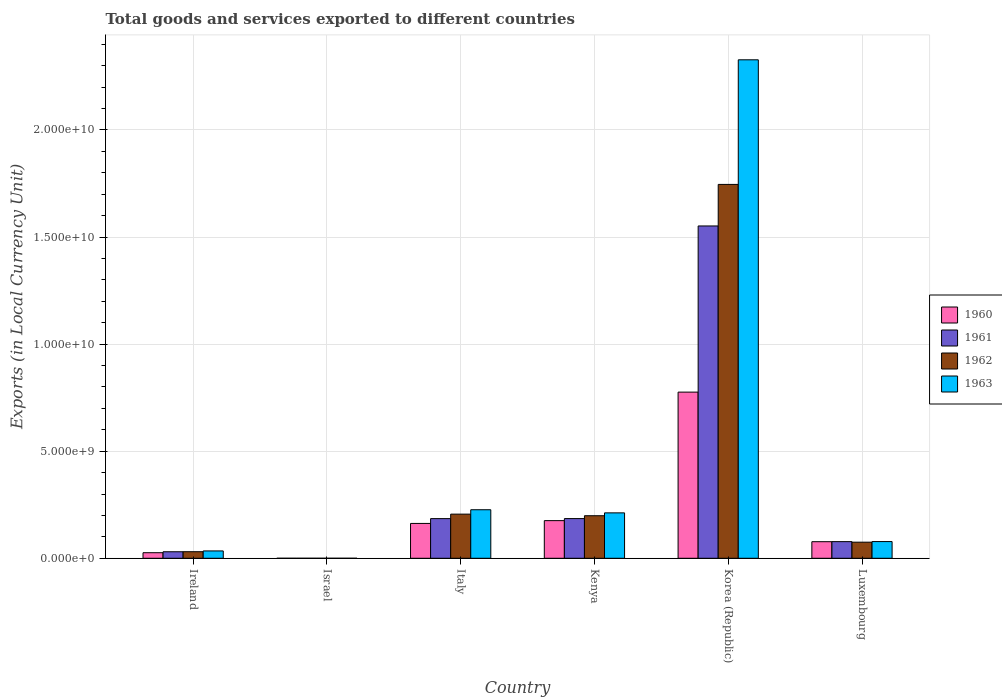How many different coloured bars are there?
Provide a short and direct response. 4. How many groups of bars are there?
Make the answer very short. 6. Are the number of bars on each tick of the X-axis equal?
Your answer should be very brief. Yes. How many bars are there on the 5th tick from the left?
Provide a short and direct response. 4. What is the label of the 4th group of bars from the left?
Offer a very short reply. Kenya. What is the Amount of goods and services exports in 1960 in Korea (Republic)?
Offer a terse response. 7.76e+09. Across all countries, what is the maximum Amount of goods and services exports in 1962?
Your answer should be very brief. 1.75e+1. Across all countries, what is the minimum Amount of goods and services exports in 1961?
Give a very brief answer. 7.24e+04. In which country was the Amount of goods and services exports in 1960 maximum?
Offer a terse response. Korea (Republic). What is the total Amount of goods and services exports in 1961 in the graph?
Ensure brevity in your answer.  2.03e+1. What is the difference between the Amount of goods and services exports in 1962 in Korea (Republic) and that in Luxembourg?
Provide a short and direct response. 1.67e+1. What is the difference between the Amount of goods and services exports in 1963 in Kenya and the Amount of goods and services exports in 1962 in Luxembourg?
Your answer should be compact. 1.37e+09. What is the average Amount of goods and services exports in 1963 per country?
Your response must be concise. 4.80e+09. What is the difference between the Amount of goods and services exports of/in 1961 and Amount of goods and services exports of/in 1962 in Korea (Republic)?
Offer a terse response. -1.94e+09. In how many countries, is the Amount of goods and services exports in 1963 greater than 6000000000 LCU?
Keep it short and to the point. 1. What is the ratio of the Amount of goods and services exports in 1961 in Italy to that in Kenya?
Keep it short and to the point. 1. Is the difference between the Amount of goods and services exports in 1961 in Italy and Kenya greater than the difference between the Amount of goods and services exports in 1962 in Italy and Kenya?
Give a very brief answer. No. What is the difference between the highest and the second highest Amount of goods and services exports in 1962?
Your answer should be compact. 1.55e+1. What is the difference between the highest and the lowest Amount of goods and services exports in 1960?
Keep it short and to the point. 7.76e+09. Is the sum of the Amount of goods and services exports in 1960 in Italy and Luxembourg greater than the maximum Amount of goods and services exports in 1962 across all countries?
Make the answer very short. No. What does the 1st bar from the right in Israel represents?
Ensure brevity in your answer.  1963. How many countries are there in the graph?
Your response must be concise. 6. Does the graph contain any zero values?
Offer a very short reply. No. How are the legend labels stacked?
Offer a terse response. Vertical. What is the title of the graph?
Ensure brevity in your answer.  Total goods and services exported to different countries. Does "1985" appear as one of the legend labels in the graph?
Your response must be concise. No. What is the label or title of the X-axis?
Give a very brief answer. Country. What is the label or title of the Y-axis?
Offer a terse response. Exports (in Local Currency Unit). What is the Exports (in Local Currency Unit) in 1960 in Ireland?
Keep it short and to the point. 2.60e+08. What is the Exports (in Local Currency Unit) in 1961 in Ireland?
Provide a short and direct response. 3.04e+08. What is the Exports (in Local Currency Unit) in 1962 in Ireland?
Give a very brief answer. 3.07e+08. What is the Exports (in Local Currency Unit) in 1963 in Ireland?
Offer a very short reply. 3.43e+08. What is the Exports (in Local Currency Unit) of 1960 in Israel?
Your answer should be compact. 6.19e+04. What is the Exports (in Local Currency Unit) of 1961 in Israel?
Your answer should be very brief. 7.24e+04. What is the Exports (in Local Currency Unit) in 1962 in Israel?
Your answer should be very brief. 1.34e+05. What is the Exports (in Local Currency Unit) of 1963 in Israel?
Offer a terse response. 1.67e+05. What is the Exports (in Local Currency Unit) of 1960 in Italy?
Your answer should be compact. 1.63e+09. What is the Exports (in Local Currency Unit) in 1961 in Italy?
Provide a succinct answer. 1.85e+09. What is the Exports (in Local Currency Unit) of 1962 in Italy?
Offer a very short reply. 2.06e+09. What is the Exports (in Local Currency Unit) of 1963 in Italy?
Provide a short and direct response. 2.27e+09. What is the Exports (in Local Currency Unit) in 1960 in Kenya?
Your answer should be compact. 1.76e+09. What is the Exports (in Local Currency Unit) in 1961 in Kenya?
Your answer should be compact. 1.85e+09. What is the Exports (in Local Currency Unit) in 1962 in Kenya?
Give a very brief answer. 1.99e+09. What is the Exports (in Local Currency Unit) in 1963 in Kenya?
Your answer should be compact. 2.12e+09. What is the Exports (in Local Currency Unit) in 1960 in Korea (Republic)?
Keep it short and to the point. 7.76e+09. What is the Exports (in Local Currency Unit) of 1961 in Korea (Republic)?
Provide a short and direct response. 1.55e+1. What is the Exports (in Local Currency Unit) of 1962 in Korea (Republic)?
Provide a short and direct response. 1.75e+1. What is the Exports (in Local Currency Unit) of 1963 in Korea (Republic)?
Ensure brevity in your answer.  2.33e+1. What is the Exports (in Local Currency Unit) in 1960 in Luxembourg?
Your answer should be very brief. 7.74e+08. What is the Exports (in Local Currency Unit) in 1961 in Luxembourg?
Ensure brevity in your answer.  7.77e+08. What is the Exports (in Local Currency Unit) in 1962 in Luxembourg?
Ensure brevity in your answer.  7.52e+08. What is the Exports (in Local Currency Unit) in 1963 in Luxembourg?
Provide a short and direct response. 7.80e+08. Across all countries, what is the maximum Exports (in Local Currency Unit) of 1960?
Keep it short and to the point. 7.76e+09. Across all countries, what is the maximum Exports (in Local Currency Unit) of 1961?
Provide a short and direct response. 1.55e+1. Across all countries, what is the maximum Exports (in Local Currency Unit) of 1962?
Make the answer very short. 1.75e+1. Across all countries, what is the maximum Exports (in Local Currency Unit) in 1963?
Provide a short and direct response. 2.33e+1. Across all countries, what is the minimum Exports (in Local Currency Unit) of 1960?
Give a very brief answer. 6.19e+04. Across all countries, what is the minimum Exports (in Local Currency Unit) of 1961?
Provide a short and direct response. 7.24e+04. Across all countries, what is the minimum Exports (in Local Currency Unit) of 1962?
Your answer should be very brief. 1.34e+05. Across all countries, what is the minimum Exports (in Local Currency Unit) of 1963?
Your response must be concise. 1.67e+05. What is the total Exports (in Local Currency Unit) of 1960 in the graph?
Your answer should be compact. 1.22e+1. What is the total Exports (in Local Currency Unit) of 1961 in the graph?
Make the answer very short. 2.03e+1. What is the total Exports (in Local Currency Unit) of 1962 in the graph?
Provide a succinct answer. 2.26e+1. What is the total Exports (in Local Currency Unit) in 1963 in the graph?
Keep it short and to the point. 2.88e+1. What is the difference between the Exports (in Local Currency Unit) of 1960 in Ireland and that in Israel?
Your answer should be very brief. 2.60e+08. What is the difference between the Exports (in Local Currency Unit) in 1961 in Ireland and that in Israel?
Your response must be concise. 3.04e+08. What is the difference between the Exports (in Local Currency Unit) of 1962 in Ireland and that in Israel?
Provide a succinct answer. 3.06e+08. What is the difference between the Exports (in Local Currency Unit) of 1963 in Ireland and that in Israel?
Your answer should be compact. 3.43e+08. What is the difference between the Exports (in Local Currency Unit) of 1960 in Ireland and that in Italy?
Offer a very short reply. -1.37e+09. What is the difference between the Exports (in Local Currency Unit) in 1961 in Ireland and that in Italy?
Make the answer very short. -1.55e+09. What is the difference between the Exports (in Local Currency Unit) in 1962 in Ireland and that in Italy?
Ensure brevity in your answer.  -1.75e+09. What is the difference between the Exports (in Local Currency Unit) of 1963 in Ireland and that in Italy?
Ensure brevity in your answer.  -1.92e+09. What is the difference between the Exports (in Local Currency Unit) of 1960 in Ireland and that in Kenya?
Your response must be concise. -1.50e+09. What is the difference between the Exports (in Local Currency Unit) in 1961 in Ireland and that in Kenya?
Your response must be concise. -1.55e+09. What is the difference between the Exports (in Local Currency Unit) of 1962 in Ireland and that in Kenya?
Provide a short and direct response. -1.68e+09. What is the difference between the Exports (in Local Currency Unit) of 1963 in Ireland and that in Kenya?
Offer a very short reply. -1.78e+09. What is the difference between the Exports (in Local Currency Unit) in 1960 in Ireland and that in Korea (Republic)?
Ensure brevity in your answer.  -7.50e+09. What is the difference between the Exports (in Local Currency Unit) of 1961 in Ireland and that in Korea (Republic)?
Your answer should be very brief. -1.52e+1. What is the difference between the Exports (in Local Currency Unit) of 1962 in Ireland and that in Korea (Republic)?
Keep it short and to the point. -1.72e+1. What is the difference between the Exports (in Local Currency Unit) of 1963 in Ireland and that in Korea (Republic)?
Give a very brief answer. -2.29e+1. What is the difference between the Exports (in Local Currency Unit) of 1960 in Ireland and that in Luxembourg?
Provide a succinct answer. -5.14e+08. What is the difference between the Exports (in Local Currency Unit) in 1961 in Ireland and that in Luxembourg?
Your response must be concise. -4.73e+08. What is the difference between the Exports (in Local Currency Unit) in 1962 in Ireland and that in Luxembourg?
Your response must be concise. -4.45e+08. What is the difference between the Exports (in Local Currency Unit) in 1963 in Ireland and that in Luxembourg?
Your answer should be compact. -4.37e+08. What is the difference between the Exports (in Local Currency Unit) in 1960 in Israel and that in Italy?
Keep it short and to the point. -1.63e+09. What is the difference between the Exports (in Local Currency Unit) in 1961 in Israel and that in Italy?
Give a very brief answer. -1.85e+09. What is the difference between the Exports (in Local Currency Unit) in 1962 in Israel and that in Italy?
Your answer should be very brief. -2.06e+09. What is the difference between the Exports (in Local Currency Unit) in 1963 in Israel and that in Italy?
Your answer should be very brief. -2.27e+09. What is the difference between the Exports (in Local Currency Unit) of 1960 in Israel and that in Kenya?
Give a very brief answer. -1.76e+09. What is the difference between the Exports (in Local Currency Unit) of 1961 in Israel and that in Kenya?
Your answer should be compact. -1.85e+09. What is the difference between the Exports (in Local Currency Unit) of 1962 in Israel and that in Kenya?
Offer a very short reply. -1.99e+09. What is the difference between the Exports (in Local Currency Unit) of 1963 in Israel and that in Kenya?
Your answer should be very brief. -2.12e+09. What is the difference between the Exports (in Local Currency Unit) in 1960 in Israel and that in Korea (Republic)?
Provide a short and direct response. -7.76e+09. What is the difference between the Exports (in Local Currency Unit) in 1961 in Israel and that in Korea (Republic)?
Provide a succinct answer. -1.55e+1. What is the difference between the Exports (in Local Currency Unit) of 1962 in Israel and that in Korea (Republic)?
Provide a short and direct response. -1.75e+1. What is the difference between the Exports (in Local Currency Unit) of 1963 in Israel and that in Korea (Republic)?
Provide a short and direct response. -2.33e+1. What is the difference between the Exports (in Local Currency Unit) of 1960 in Israel and that in Luxembourg?
Make the answer very short. -7.74e+08. What is the difference between the Exports (in Local Currency Unit) in 1961 in Israel and that in Luxembourg?
Keep it short and to the point. -7.77e+08. What is the difference between the Exports (in Local Currency Unit) in 1962 in Israel and that in Luxembourg?
Offer a terse response. -7.52e+08. What is the difference between the Exports (in Local Currency Unit) in 1963 in Israel and that in Luxembourg?
Make the answer very short. -7.79e+08. What is the difference between the Exports (in Local Currency Unit) in 1960 in Italy and that in Kenya?
Give a very brief answer. -1.31e+08. What is the difference between the Exports (in Local Currency Unit) in 1961 in Italy and that in Kenya?
Ensure brevity in your answer.  -1.45e+06. What is the difference between the Exports (in Local Currency Unit) of 1962 in Italy and that in Kenya?
Keep it short and to the point. 7.40e+07. What is the difference between the Exports (in Local Currency Unit) in 1963 in Italy and that in Kenya?
Your response must be concise. 1.46e+08. What is the difference between the Exports (in Local Currency Unit) in 1960 in Italy and that in Korea (Republic)?
Give a very brief answer. -6.13e+09. What is the difference between the Exports (in Local Currency Unit) of 1961 in Italy and that in Korea (Republic)?
Your response must be concise. -1.37e+1. What is the difference between the Exports (in Local Currency Unit) of 1962 in Italy and that in Korea (Republic)?
Keep it short and to the point. -1.54e+1. What is the difference between the Exports (in Local Currency Unit) in 1963 in Italy and that in Korea (Republic)?
Keep it short and to the point. -2.10e+1. What is the difference between the Exports (in Local Currency Unit) in 1960 in Italy and that in Luxembourg?
Offer a very short reply. 8.53e+08. What is the difference between the Exports (in Local Currency Unit) of 1961 in Italy and that in Luxembourg?
Provide a succinct answer. 1.07e+09. What is the difference between the Exports (in Local Currency Unit) of 1962 in Italy and that in Luxembourg?
Provide a short and direct response. 1.31e+09. What is the difference between the Exports (in Local Currency Unit) of 1963 in Italy and that in Luxembourg?
Keep it short and to the point. 1.49e+09. What is the difference between the Exports (in Local Currency Unit) in 1960 in Kenya and that in Korea (Republic)?
Provide a short and direct response. -6.00e+09. What is the difference between the Exports (in Local Currency Unit) of 1961 in Kenya and that in Korea (Republic)?
Your answer should be compact. -1.37e+1. What is the difference between the Exports (in Local Currency Unit) of 1962 in Kenya and that in Korea (Republic)?
Ensure brevity in your answer.  -1.55e+1. What is the difference between the Exports (in Local Currency Unit) of 1963 in Kenya and that in Korea (Republic)?
Provide a short and direct response. -2.12e+1. What is the difference between the Exports (in Local Currency Unit) of 1960 in Kenya and that in Luxembourg?
Make the answer very short. 9.84e+08. What is the difference between the Exports (in Local Currency Unit) in 1961 in Kenya and that in Luxembourg?
Your answer should be compact. 1.08e+09. What is the difference between the Exports (in Local Currency Unit) in 1962 in Kenya and that in Luxembourg?
Your response must be concise. 1.23e+09. What is the difference between the Exports (in Local Currency Unit) of 1963 in Kenya and that in Luxembourg?
Provide a succinct answer. 1.34e+09. What is the difference between the Exports (in Local Currency Unit) in 1960 in Korea (Republic) and that in Luxembourg?
Your answer should be very brief. 6.98e+09. What is the difference between the Exports (in Local Currency Unit) of 1961 in Korea (Republic) and that in Luxembourg?
Your response must be concise. 1.47e+1. What is the difference between the Exports (in Local Currency Unit) of 1962 in Korea (Republic) and that in Luxembourg?
Make the answer very short. 1.67e+1. What is the difference between the Exports (in Local Currency Unit) of 1963 in Korea (Republic) and that in Luxembourg?
Your response must be concise. 2.25e+1. What is the difference between the Exports (in Local Currency Unit) of 1960 in Ireland and the Exports (in Local Currency Unit) of 1961 in Israel?
Offer a terse response. 2.60e+08. What is the difference between the Exports (in Local Currency Unit) in 1960 in Ireland and the Exports (in Local Currency Unit) in 1962 in Israel?
Provide a short and direct response. 2.60e+08. What is the difference between the Exports (in Local Currency Unit) in 1960 in Ireland and the Exports (in Local Currency Unit) in 1963 in Israel?
Provide a short and direct response. 2.60e+08. What is the difference between the Exports (in Local Currency Unit) in 1961 in Ireland and the Exports (in Local Currency Unit) in 1962 in Israel?
Give a very brief answer. 3.04e+08. What is the difference between the Exports (in Local Currency Unit) of 1961 in Ireland and the Exports (in Local Currency Unit) of 1963 in Israel?
Your answer should be very brief. 3.04e+08. What is the difference between the Exports (in Local Currency Unit) of 1962 in Ireland and the Exports (in Local Currency Unit) of 1963 in Israel?
Provide a succinct answer. 3.06e+08. What is the difference between the Exports (in Local Currency Unit) in 1960 in Ireland and the Exports (in Local Currency Unit) in 1961 in Italy?
Your answer should be very brief. -1.59e+09. What is the difference between the Exports (in Local Currency Unit) in 1960 in Ireland and the Exports (in Local Currency Unit) in 1962 in Italy?
Provide a succinct answer. -1.80e+09. What is the difference between the Exports (in Local Currency Unit) in 1960 in Ireland and the Exports (in Local Currency Unit) in 1963 in Italy?
Keep it short and to the point. -2.01e+09. What is the difference between the Exports (in Local Currency Unit) in 1961 in Ireland and the Exports (in Local Currency Unit) in 1962 in Italy?
Provide a succinct answer. -1.76e+09. What is the difference between the Exports (in Local Currency Unit) of 1961 in Ireland and the Exports (in Local Currency Unit) of 1963 in Italy?
Offer a terse response. -1.96e+09. What is the difference between the Exports (in Local Currency Unit) of 1962 in Ireland and the Exports (in Local Currency Unit) of 1963 in Italy?
Give a very brief answer. -1.96e+09. What is the difference between the Exports (in Local Currency Unit) of 1960 in Ireland and the Exports (in Local Currency Unit) of 1961 in Kenya?
Offer a very short reply. -1.59e+09. What is the difference between the Exports (in Local Currency Unit) of 1960 in Ireland and the Exports (in Local Currency Unit) of 1962 in Kenya?
Your response must be concise. -1.73e+09. What is the difference between the Exports (in Local Currency Unit) in 1960 in Ireland and the Exports (in Local Currency Unit) in 1963 in Kenya?
Your answer should be very brief. -1.86e+09. What is the difference between the Exports (in Local Currency Unit) of 1961 in Ireland and the Exports (in Local Currency Unit) of 1962 in Kenya?
Keep it short and to the point. -1.68e+09. What is the difference between the Exports (in Local Currency Unit) in 1961 in Ireland and the Exports (in Local Currency Unit) in 1963 in Kenya?
Your answer should be very brief. -1.82e+09. What is the difference between the Exports (in Local Currency Unit) of 1962 in Ireland and the Exports (in Local Currency Unit) of 1963 in Kenya?
Give a very brief answer. -1.81e+09. What is the difference between the Exports (in Local Currency Unit) of 1960 in Ireland and the Exports (in Local Currency Unit) of 1961 in Korea (Republic)?
Give a very brief answer. -1.53e+1. What is the difference between the Exports (in Local Currency Unit) of 1960 in Ireland and the Exports (in Local Currency Unit) of 1962 in Korea (Republic)?
Your response must be concise. -1.72e+1. What is the difference between the Exports (in Local Currency Unit) in 1960 in Ireland and the Exports (in Local Currency Unit) in 1963 in Korea (Republic)?
Your response must be concise. -2.30e+1. What is the difference between the Exports (in Local Currency Unit) in 1961 in Ireland and the Exports (in Local Currency Unit) in 1962 in Korea (Republic)?
Your response must be concise. -1.72e+1. What is the difference between the Exports (in Local Currency Unit) in 1961 in Ireland and the Exports (in Local Currency Unit) in 1963 in Korea (Republic)?
Provide a short and direct response. -2.30e+1. What is the difference between the Exports (in Local Currency Unit) of 1962 in Ireland and the Exports (in Local Currency Unit) of 1963 in Korea (Republic)?
Ensure brevity in your answer.  -2.30e+1. What is the difference between the Exports (in Local Currency Unit) of 1960 in Ireland and the Exports (in Local Currency Unit) of 1961 in Luxembourg?
Offer a terse response. -5.17e+08. What is the difference between the Exports (in Local Currency Unit) in 1960 in Ireland and the Exports (in Local Currency Unit) in 1962 in Luxembourg?
Offer a terse response. -4.92e+08. What is the difference between the Exports (in Local Currency Unit) of 1960 in Ireland and the Exports (in Local Currency Unit) of 1963 in Luxembourg?
Offer a terse response. -5.20e+08. What is the difference between the Exports (in Local Currency Unit) in 1961 in Ireland and the Exports (in Local Currency Unit) in 1962 in Luxembourg?
Make the answer very short. -4.48e+08. What is the difference between the Exports (in Local Currency Unit) of 1961 in Ireland and the Exports (in Local Currency Unit) of 1963 in Luxembourg?
Offer a terse response. -4.76e+08. What is the difference between the Exports (in Local Currency Unit) of 1962 in Ireland and the Exports (in Local Currency Unit) of 1963 in Luxembourg?
Ensure brevity in your answer.  -4.73e+08. What is the difference between the Exports (in Local Currency Unit) of 1960 in Israel and the Exports (in Local Currency Unit) of 1961 in Italy?
Offer a terse response. -1.85e+09. What is the difference between the Exports (in Local Currency Unit) in 1960 in Israel and the Exports (in Local Currency Unit) in 1962 in Italy?
Keep it short and to the point. -2.06e+09. What is the difference between the Exports (in Local Currency Unit) of 1960 in Israel and the Exports (in Local Currency Unit) of 1963 in Italy?
Offer a terse response. -2.27e+09. What is the difference between the Exports (in Local Currency Unit) in 1961 in Israel and the Exports (in Local Currency Unit) in 1962 in Italy?
Make the answer very short. -2.06e+09. What is the difference between the Exports (in Local Currency Unit) of 1961 in Israel and the Exports (in Local Currency Unit) of 1963 in Italy?
Your answer should be compact. -2.27e+09. What is the difference between the Exports (in Local Currency Unit) in 1962 in Israel and the Exports (in Local Currency Unit) in 1963 in Italy?
Your response must be concise. -2.27e+09. What is the difference between the Exports (in Local Currency Unit) of 1960 in Israel and the Exports (in Local Currency Unit) of 1961 in Kenya?
Give a very brief answer. -1.85e+09. What is the difference between the Exports (in Local Currency Unit) in 1960 in Israel and the Exports (in Local Currency Unit) in 1962 in Kenya?
Your response must be concise. -1.99e+09. What is the difference between the Exports (in Local Currency Unit) of 1960 in Israel and the Exports (in Local Currency Unit) of 1963 in Kenya?
Your answer should be very brief. -2.12e+09. What is the difference between the Exports (in Local Currency Unit) of 1961 in Israel and the Exports (in Local Currency Unit) of 1962 in Kenya?
Provide a succinct answer. -1.99e+09. What is the difference between the Exports (in Local Currency Unit) in 1961 in Israel and the Exports (in Local Currency Unit) in 1963 in Kenya?
Offer a terse response. -2.12e+09. What is the difference between the Exports (in Local Currency Unit) in 1962 in Israel and the Exports (in Local Currency Unit) in 1963 in Kenya?
Keep it short and to the point. -2.12e+09. What is the difference between the Exports (in Local Currency Unit) of 1960 in Israel and the Exports (in Local Currency Unit) of 1961 in Korea (Republic)?
Give a very brief answer. -1.55e+1. What is the difference between the Exports (in Local Currency Unit) of 1960 in Israel and the Exports (in Local Currency Unit) of 1962 in Korea (Republic)?
Your answer should be compact. -1.75e+1. What is the difference between the Exports (in Local Currency Unit) in 1960 in Israel and the Exports (in Local Currency Unit) in 1963 in Korea (Republic)?
Provide a succinct answer. -2.33e+1. What is the difference between the Exports (in Local Currency Unit) in 1961 in Israel and the Exports (in Local Currency Unit) in 1962 in Korea (Republic)?
Keep it short and to the point. -1.75e+1. What is the difference between the Exports (in Local Currency Unit) of 1961 in Israel and the Exports (in Local Currency Unit) of 1963 in Korea (Republic)?
Offer a terse response. -2.33e+1. What is the difference between the Exports (in Local Currency Unit) in 1962 in Israel and the Exports (in Local Currency Unit) in 1963 in Korea (Republic)?
Keep it short and to the point. -2.33e+1. What is the difference between the Exports (in Local Currency Unit) in 1960 in Israel and the Exports (in Local Currency Unit) in 1961 in Luxembourg?
Your response must be concise. -7.77e+08. What is the difference between the Exports (in Local Currency Unit) in 1960 in Israel and the Exports (in Local Currency Unit) in 1962 in Luxembourg?
Your answer should be compact. -7.52e+08. What is the difference between the Exports (in Local Currency Unit) of 1960 in Israel and the Exports (in Local Currency Unit) of 1963 in Luxembourg?
Ensure brevity in your answer.  -7.80e+08. What is the difference between the Exports (in Local Currency Unit) in 1961 in Israel and the Exports (in Local Currency Unit) in 1962 in Luxembourg?
Keep it short and to the point. -7.52e+08. What is the difference between the Exports (in Local Currency Unit) in 1961 in Israel and the Exports (in Local Currency Unit) in 1963 in Luxembourg?
Provide a short and direct response. -7.80e+08. What is the difference between the Exports (in Local Currency Unit) of 1962 in Israel and the Exports (in Local Currency Unit) of 1963 in Luxembourg?
Provide a short and direct response. -7.80e+08. What is the difference between the Exports (in Local Currency Unit) in 1960 in Italy and the Exports (in Local Currency Unit) in 1961 in Kenya?
Your answer should be compact. -2.27e+08. What is the difference between the Exports (in Local Currency Unit) in 1960 in Italy and the Exports (in Local Currency Unit) in 1962 in Kenya?
Your answer should be compact. -3.60e+08. What is the difference between the Exports (in Local Currency Unit) of 1960 in Italy and the Exports (in Local Currency Unit) of 1963 in Kenya?
Provide a short and direct response. -4.94e+08. What is the difference between the Exports (in Local Currency Unit) of 1961 in Italy and the Exports (in Local Currency Unit) of 1962 in Kenya?
Your answer should be compact. -1.35e+08. What is the difference between the Exports (in Local Currency Unit) of 1961 in Italy and the Exports (in Local Currency Unit) of 1963 in Kenya?
Offer a very short reply. -2.68e+08. What is the difference between the Exports (in Local Currency Unit) in 1962 in Italy and the Exports (in Local Currency Unit) in 1963 in Kenya?
Ensure brevity in your answer.  -5.95e+07. What is the difference between the Exports (in Local Currency Unit) of 1960 in Italy and the Exports (in Local Currency Unit) of 1961 in Korea (Republic)?
Make the answer very short. -1.39e+1. What is the difference between the Exports (in Local Currency Unit) of 1960 in Italy and the Exports (in Local Currency Unit) of 1962 in Korea (Republic)?
Provide a short and direct response. -1.58e+1. What is the difference between the Exports (in Local Currency Unit) in 1960 in Italy and the Exports (in Local Currency Unit) in 1963 in Korea (Republic)?
Your answer should be compact. -2.16e+1. What is the difference between the Exports (in Local Currency Unit) in 1961 in Italy and the Exports (in Local Currency Unit) in 1962 in Korea (Republic)?
Your answer should be very brief. -1.56e+1. What is the difference between the Exports (in Local Currency Unit) of 1961 in Italy and the Exports (in Local Currency Unit) of 1963 in Korea (Republic)?
Provide a succinct answer. -2.14e+1. What is the difference between the Exports (in Local Currency Unit) of 1962 in Italy and the Exports (in Local Currency Unit) of 1963 in Korea (Republic)?
Keep it short and to the point. -2.12e+1. What is the difference between the Exports (in Local Currency Unit) in 1960 in Italy and the Exports (in Local Currency Unit) in 1961 in Luxembourg?
Your answer should be very brief. 8.50e+08. What is the difference between the Exports (in Local Currency Unit) in 1960 in Italy and the Exports (in Local Currency Unit) in 1962 in Luxembourg?
Your response must be concise. 8.75e+08. What is the difference between the Exports (in Local Currency Unit) in 1960 in Italy and the Exports (in Local Currency Unit) in 1963 in Luxembourg?
Your answer should be very brief. 8.47e+08. What is the difference between the Exports (in Local Currency Unit) of 1961 in Italy and the Exports (in Local Currency Unit) of 1962 in Luxembourg?
Ensure brevity in your answer.  1.10e+09. What is the difference between the Exports (in Local Currency Unit) in 1961 in Italy and the Exports (in Local Currency Unit) in 1963 in Luxembourg?
Provide a short and direct response. 1.07e+09. What is the difference between the Exports (in Local Currency Unit) of 1962 in Italy and the Exports (in Local Currency Unit) of 1963 in Luxembourg?
Offer a terse response. 1.28e+09. What is the difference between the Exports (in Local Currency Unit) of 1960 in Kenya and the Exports (in Local Currency Unit) of 1961 in Korea (Republic)?
Your answer should be compact. -1.38e+1. What is the difference between the Exports (in Local Currency Unit) of 1960 in Kenya and the Exports (in Local Currency Unit) of 1962 in Korea (Republic)?
Keep it short and to the point. -1.57e+1. What is the difference between the Exports (in Local Currency Unit) of 1960 in Kenya and the Exports (in Local Currency Unit) of 1963 in Korea (Republic)?
Offer a terse response. -2.15e+1. What is the difference between the Exports (in Local Currency Unit) in 1961 in Kenya and the Exports (in Local Currency Unit) in 1962 in Korea (Republic)?
Provide a short and direct response. -1.56e+1. What is the difference between the Exports (in Local Currency Unit) in 1961 in Kenya and the Exports (in Local Currency Unit) in 1963 in Korea (Republic)?
Keep it short and to the point. -2.14e+1. What is the difference between the Exports (in Local Currency Unit) of 1962 in Kenya and the Exports (in Local Currency Unit) of 1963 in Korea (Republic)?
Offer a terse response. -2.13e+1. What is the difference between the Exports (in Local Currency Unit) of 1960 in Kenya and the Exports (in Local Currency Unit) of 1961 in Luxembourg?
Make the answer very short. 9.81e+08. What is the difference between the Exports (in Local Currency Unit) of 1960 in Kenya and the Exports (in Local Currency Unit) of 1962 in Luxembourg?
Give a very brief answer. 1.01e+09. What is the difference between the Exports (in Local Currency Unit) in 1960 in Kenya and the Exports (in Local Currency Unit) in 1963 in Luxembourg?
Your response must be concise. 9.78e+08. What is the difference between the Exports (in Local Currency Unit) of 1961 in Kenya and the Exports (in Local Currency Unit) of 1962 in Luxembourg?
Offer a terse response. 1.10e+09. What is the difference between the Exports (in Local Currency Unit) of 1961 in Kenya and the Exports (in Local Currency Unit) of 1963 in Luxembourg?
Give a very brief answer. 1.07e+09. What is the difference between the Exports (in Local Currency Unit) in 1962 in Kenya and the Exports (in Local Currency Unit) in 1963 in Luxembourg?
Provide a short and direct response. 1.21e+09. What is the difference between the Exports (in Local Currency Unit) of 1960 in Korea (Republic) and the Exports (in Local Currency Unit) of 1961 in Luxembourg?
Keep it short and to the point. 6.98e+09. What is the difference between the Exports (in Local Currency Unit) of 1960 in Korea (Republic) and the Exports (in Local Currency Unit) of 1962 in Luxembourg?
Offer a very short reply. 7.01e+09. What is the difference between the Exports (in Local Currency Unit) in 1960 in Korea (Republic) and the Exports (in Local Currency Unit) in 1963 in Luxembourg?
Your answer should be very brief. 6.98e+09. What is the difference between the Exports (in Local Currency Unit) in 1961 in Korea (Republic) and the Exports (in Local Currency Unit) in 1962 in Luxembourg?
Offer a very short reply. 1.48e+1. What is the difference between the Exports (in Local Currency Unit) of 1961 in Korea (Republic) and the Exports (in Local Currency Unit) of 1963 in Luxembourg?
Give a very brief answer. 1.47e+1. What is the difference between the Exports (in Local Currency Unit) of 1962 in Korea (Republic) and the Exports (in Local Currency Unit) of 1963 in Luxembourg?
Provide a succinct answer. 1.67e+1. What is the average Exports (in Local Currency Unit) in 1960 per country?
Your answer should be compact. 2.03e+09. What is the average Exports (in Local Currency Unit) in 1961 per country?
Give a very brief answer. 3.38e+09. What is the average Exports (in Local Currency Unit) in 1962 per country?
Your answer should be very brief. 3.76e+09. What is the average Exports (in Local Currency Unit) of 1963 per country?
Your answer should be very brief. 4.80e+09. What is the difference between the Exports (in Local Currency Unit) of 1960 and Exports (in Local Currency Unit) of 1961 in Ireland?
Offer a terse response. -4.43e+07. What is the difference between the Exports (in Local Currency Unit) of 1960 and Exports (in Local Currency Unit) of 1962 in Ireland?
Offer a very short reply. -4.69e+07. What is the difference between the Exports (in Local Currency Unit) in 1960 and Exports (in Local Currency Unit) in 1963 in Ireland?
Provide a short and direct response. -8.33e+07. What is the difference between the Exports (in Local Currency Unit) in 1961 and Exports (in Local Currency Unit) in 1962 in Ireland?
Offer a terse response. -2.58e+06. What is the difference between the Exports (in Local Currency Unit) of 1961 and Exports (in Local Currency Unit) of 1963 in Ireland?
Your answer should be compact. -3.90e+07. What is the difference between the Exports (in Local Currency Unit) of 1962 and Exports (in Local Currency Unit) of 1963 in Ireland?
Provide a short and direct response. -3.64e+07. What is the difference between the Exports (in Local Currency Unit) in 1960 and Exports (in Local Currency Unit) in 1961 in Israel?
Make the answer very short. -1.05e+04. What is the difference between the Exports (in Local Currency Unit) in 1960 and Exports (in Local Currency Unit) in 1962 in Israel?
Your answer should be very brief. -7.21e+04. What is the difference between the Exports (in Local Currency Unit) in 1960 and Exports (in Local Currency Unit) in 1963 in Israel?
Provide a succinct answer. -1.06e+05. What is the difference between the Exports (in Local Currency Unit) of 1961 and Exports (in Local Currency Unit) of 1962 in Israel?
Give a very brief answer. -6.16e+04. What is the difference between the Exports (in Local Currency Unit) of 1961 and Exports (in Local Currency Unit) of 1963 in Israel?
Your response must be concise. -9.50e+04. What is the difference between the Exports (in Local Currency Unit) of 1962 and Exports (in Local Currency Unit) of 1963 in Israel?
Your response must be concise. -3.34e+04. What is the difference between the Exports (in Local Currency Unit) in 1960 and Exports (in Local Currency Unit) in 1961 in Italy?
Offer a terse response. -2.25e+08. What is the difference between the Exports (in Local Currency Unit) of 1960 and Exports (in Local Currency Unit) of 1962 in Italy?
Give a very brief answer. -4.34e+08. What is the difference between the Exports (in Local Currency Unit) of 1960 and Exports (in Local Currency Unit) of 1963 in Italy?
Provide a short and direct response. -6.40e+08. What is the difference between the Exports (in Local Currency Unit) of 1961 and Exports (in Local Currency Unit) of 1962 in Italy?
Your response must be concise. -2.09e+08. What is the difference between the Exports (in Local Currency Unit) in 1961 and Exports (in Local Currency Unit) in 1963 in Italy?
Your response must be concise. -4.14e+08. What is the difference between the Exports (in Local Currency Unit) of 1962 and Exports (in Local Currency Unit) of 1963 in Italy?
Your answer should be compact. -2.05e+08. What is the difference between the Exports (in Local Currency Unit) of 1960 and Exports (in Local Currency Unit) of 1961 in Kenya?
Make the answer very short. -9.56e+07. What is the difference between the Exports (in Local Currency Unit) in 1960 and Exports (in Local Currency Unit) in 1962 in Kenya?
Ensure brevity in your answer.  -2.29e+08. What is the difference between the Exports (in Local Currency Unit) of 1960 and Exports (in Local Currency Unit) of 1963 in Kenya?
Your answer should be very brief. -3.63e+08. What is the difference between the Exports (in Local Currency Unit) in 1961 and Exports (in Local Currency Unit) in 1962 in Kenya?
Your answer should be very brief. -1.33e+08. What is the difference between the Exports (in Local Currency Unit) of 1961 and Exports (in Local Currency Unit) of 1963 in Kenya?
Ensure brevity in your answer.  -2.67e+08. What is the difference between the Exports (in Local Currency Unit) of 1962 and Exports (in Local Currency Unit) of 1963 in Kenya?
Ensure brevity in your answer.  -1.34e+08. What is the difference between the Exports (in Local Currency Unit) of 1960 and Exports (in Local Currency Unit) of 1961 in Korea (Republic)?
Offer a terse response. -7.76e+09. What is the difference between the Exports (in Local Currency Unit) in 1960 and Exports (in Local Currency Unit) in 1962 in Korea (Republic)?
Offer a terse response. -9.70e+09. What is the difference between the Exports (in Local Currency Unit) of 1960 and Exports (in Local Currency Unit) of 1963 in Korea (Republic)?
Provide a short and direct response. -1.55e+1. What is the difference between the Exports (in Local Currency Unit) of 1961 and Exports (in Local Currency Unit) of 1962 in Korea (Republic)?
Offer a very short reply. -1.94e+09. What is the difference between the Exports (in Local Currency Unit) of 1961 and Exports (in Local Currency Unit) of 1963 in Korea (Republic)?
Offer a terse response. -7.76e+09. What is the difference between the Exports (in Local Currency Unit) of 1962 and Exports (in Local Currency Unit) of 1963 in Korea (Republic)?
Ensure brevity in your answer.  -5.82e+09. What is the difference between the Exports (in Local Currency Unit) in 1960 and Exports (in Local Currency Unit) in 1961 in Luxembourg?
Your answer should be very brief. -2.86e+06. What is the difference between the Exports (in Local Currency Unit) of 1960 and Exports (in Local Currency Unit) of 1962 in Luxembourg?
Give a very brief answer. 2.23e+07. What is the difference between the Exports (in Local Currency Unit) of 1960 and Exports (in Local Currency Unit) of 1963 in Luxembourg?
Your response must be concise. -5.65e+06. What is the difference between the Exports (in Local Currency Unit) in 1961 and Exports (in Local Currency Unit) in 1962 in Luxembourg?
Make the answer very short. 2.52e+07. What is the difference between the Exports (in Local Currency Unit) of 1961 and Exports (in Local Currency Unit) of 1963 in Luxembourg?
Your response must be concise. -2.79e+06. What is the difference between the Exports (in Local Currency Unit) in 1962 and Exports (in Local Currency Unit) in 1963 in Luxembourg?
Offer a very short reply. -2.80e+07. What is the ratio of the Exports (in Local Currency Unit) of 1960 in Ireland to that in Israel?
Your response must be concise. 4195.01. What is the ratio of the Exports (in Local Currency Unit) in 1961 in Ireland to that in Israel?
Make the answer very short. 4198.66. What is the ratio of the Exports (in Local Currency Unit) in 1962 in Ireland to that in Israel?
Your response must be concise. 2287.81. What is the ratio of the Exports (in Local Currency Unit) in 1963 in Ireland to that in Israel?
Offer a terse response. 2048.97. What is the ratio of the Exports (in Local Currency Unit) of 1960 in Ireland to that in Italy?
Ensure brevity in your answer.  0.16. What is the ratio of the Exports (in Local Currency Unit) of 1961 in Ireland to that in Italy?
Keep it short and to the point. 0.16. What is the ratio of the Exports (in Local Currency Unit) of 1962 in Ireland to that in Italy?
Provide a short and direct response. 0.15. What is the ratio of the Exports (in Local Currency Unit) of 1963 in Ireland to that in Italy?
Make the answer very short. 0.15. What is the ratio of the Exports (in Local Currency Unit) in 1960 in Ireland to that in Kenya?
Your answer should be compact. 0.15. What is the ratio of the Exports (in Local Currency Unit) of 1961 in Ireland to that in Kenya?
Your answer should be compact. 0.16. What is the ratio of the Exports (in Local Currency Unit) in 1962 in Ireland to that in Kenya?
Your answer should be compact. 0.15. What is the ratio of the Exports (in Local Currency Unit) in 1963 in Ireland to that in Kenya?
Provide a succinct answer. 0.16. What is the ratio of the Exports (in Local Currency Unit) in 1960 in Ireland to that in Korea (Republic)?
Provide a succinct answer. 0.03. What is the ratio of the Exports (in Local Currency Unit) of 1961 in Ireland to that in Korea (Republic)?
Ensure brevity in your answer.  0.02. What is the ratio of the Exports (in Local Currency Unit) in 1962 in Ireland to that in Korea (Republic)?
Make the answer very short. 0.02. What is the ratio of the Exports (in Local Currency Unit) in 1963 in Ireland to that in Korea (Republic)?
Your answer should be compact. 0.01. What is the ratio of the Exports (in Local Currency Unit) in 1960 in Ireland to that in Luxembourg?
Provide a short and direct response. 0.34. What is the ratio of the Exports (in Local Currency Unit) in 1961 in Ireland to that in Luxembourg?
Ensure brevity in your answer.  0.39. What is the ratio of the Exports (in Local Currency Unit) in 1962 in Ireland to that in Luxembourg?
Your answer should be compact. 0.41. What is the ratio of the Exports (in Local Currency Unit) of 1963 in Ireland to that in Luxembourg?
Your response must be concise. 0.44. What is the ratio of the Exports (in Local Currency Unit) in 1960 in Israel to that in Italy?
Your answer should be compact. 0. What is the ratio of the Exports (in Local Currency Unit) in 1961 in Israel to that in Italy?
Give a very brief answer. 0. What is the ratio of the Exports (in Local Currency Unit) of 1961 in Israel to that in Kenya?
Your answer should be very brief. 0. What is the ratio of the Exports (in Local Currency Unit) in 1961 in Israel to that in Korea (Republic)?
Provide a short and direct response. 0. What is the ratio of the Exports (in Local Currency Unit) in 1961 in Israel to that in Luxembourg?
Keep it short and to the point. 0. What is the ratio of the Exports (in Local Currency Unit) of 1963 in Israel to that in Luxembourg?
Provide a succinct answer. 0. What is the ratio of the Exports (in Local Currency Unit) in 1960 in Italy to that in Kenya?
Offer a terse response. 0.93. What is the ratio of the Exports (in Local Currency Unit) in 1961 in Italy to that in Kenya?
Give a very brief answer. 1. What is the ratio of the Exports (in Local Currency Unit) of 1962 in Italy to that in Kenya?
Offer a very short reply. 1.04. What is the ratio of the Exports (in Local Currency Unit) of 1963 in Italy to that in Kenya?
Keep it short and to the point. 1.07. What is the ratio of the Exports (in Local Currency Unit) of 1960 in Italy to that in Korea (Republic)?
Ensure brevity in your answer.  0.21. What is the ratio of the Exports (in Local Currency Unit) in 1961 in Italy to that in Korea (Republic)?
Offer a very short reply. 0.12. What is the ratio of the Exports (in Local Currency Unit) of 1962 in Italy to that in Korea (Republic)?
Offer a very short reply. 0.12. What is the ratio of the Exports (in Local Currency Unit) in 1963 in Italy to that in Korea (Republic)?
Offer a very short reply. 0.1. What is the ratio of the Exports (in Local Currency Unit) in 1960 in Italy to that in Luxembourg?
Offer a very short reply. 2.1. What is the ratio of the Exports (in Local Currency Unit) of 1961 in Italy to that in Luxembourg?
Provide a succinct answer. 2.38. What is the ratio of the Exports (in Local Currency Unit) of 1962 in Italy to that in Luxembourg?
Offer a terse response. 2.74. What is the ratio of the Exports (in Local Currency Unit) in 1963 in Italy to that in Luxembourg?
Keep it short and to the point. 2.91. What is the ratio of the Exports (in Local Currency Unit) in 1960 in Kenya to that in Korea (Republic)?
Your response must be concise. 0.23. What is the ratio of the Exports (in Local Currency Unit) in 1961 in Kenya to that in Korea (Republic)?
Your answer should be compact. 0.12. What is the ratio of the Exports (in Local Currency Unit) in 1962 in Kenya to that in Korea (Republic)?
Provide a short and direct response. 0.11. What is the ratio of the Exports (in Local Currency Unit) in 1963 in Kenya to that in Korea (Republic)?
Your answer should be very brief. 0.09. What is the ratio of the Exports (in Local Currency Unit) in 1960 in Kenya to that in Luxembourg?
Make the answer very short. 2.27. What is the ratio of the Exports (in Local Currency Unit) of 1961 in Kenya to that in Luxembourg?
Provide a short and direct response. 2.39. What is the ratio of the Exports (in Local Currency Unit) in 1962 in Kenya to that in Luxembourg?
Give a very brief answer. 2.64. What is the ratio of the Exports (in Local Currency Unit) of 1963 in Kenya to that in Luxembourg?
Give a very brief answer. 2.72. What is the ratio of the Exports (in Local Currency Unit) of 1960 in Korea (Republic) to that in Luxembourg?
Your response must be concise. 10.02. What is the ratio of the Exports (in Local Currency Unit) in 1961 in Korea (Republic) to that in Luxembourg?
Make the answer very short. 19.97. What is the ratio of the Exports (in Local Currency Unit) in 1962 in Korea (Republic) to that in Luxembourg?
Keep it short and to the point. 23.22. What is the ratio of the Exports (in Local Currency Unit) of 1963 in Korea (Republic) to that in Luxembourg?
Provide a short and direct response. 29.85. What is the difference between the highest and the second highest Exports (in Local Currency Unit) of 1960?
Make the answer very short. 6.00e+09. What is the difference between the highest and the second highest Exports (in Local Currency Unit) of 1961?
Keep it short and to the point. 1.37e+1. What is the difference between the highest and the second highest Exports (in Local Currency Unit) in 1962?
Your response must be concise. 1.54e+1. What is the difference between the highest and the second highest Exports (in Local Currency Unit) in 1963?
Your answer should be compact. 2.10e+1. What is the difference between the highest and the lowest Exports (in Local Currency Unit) of 1960?
Ensure brevity in your answer.  7.76e+09. What is the difference between the highest and the lowest Exports (in Local Currency Unit) of 1961?
Offer a terse response. 1.55e+1. What is the difference between the highest and the lowest Exports (in Local Currency Unit) in 1962?
Your answer should be very brief. 1.75e+1. What is the difference between the highest and the lowest Exports (in Local Currency Unit) of 1963?
Provide a succinct answer. 2.33e+1. 